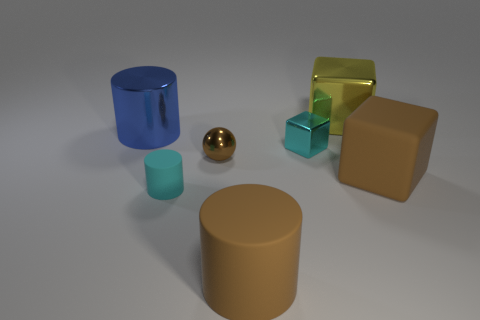Subtract all brown cylinders. Subtract all brown balls. How many cylinders are left? 2 Add 1 small cylinders. How many objects exist? 8 Subtract all balls. How many objects are left? 6 Add 1 small cyan rubber cylinders. How many small cyan rubber cylinders exist? 2 Subtract 0 blue blocks. How many objects are left? 7 Subtract all cyan metal blocks. Subtract all tiny things. How many objects are left? 3 Add 2 small metal objects. How many small metal objects are left? 4 